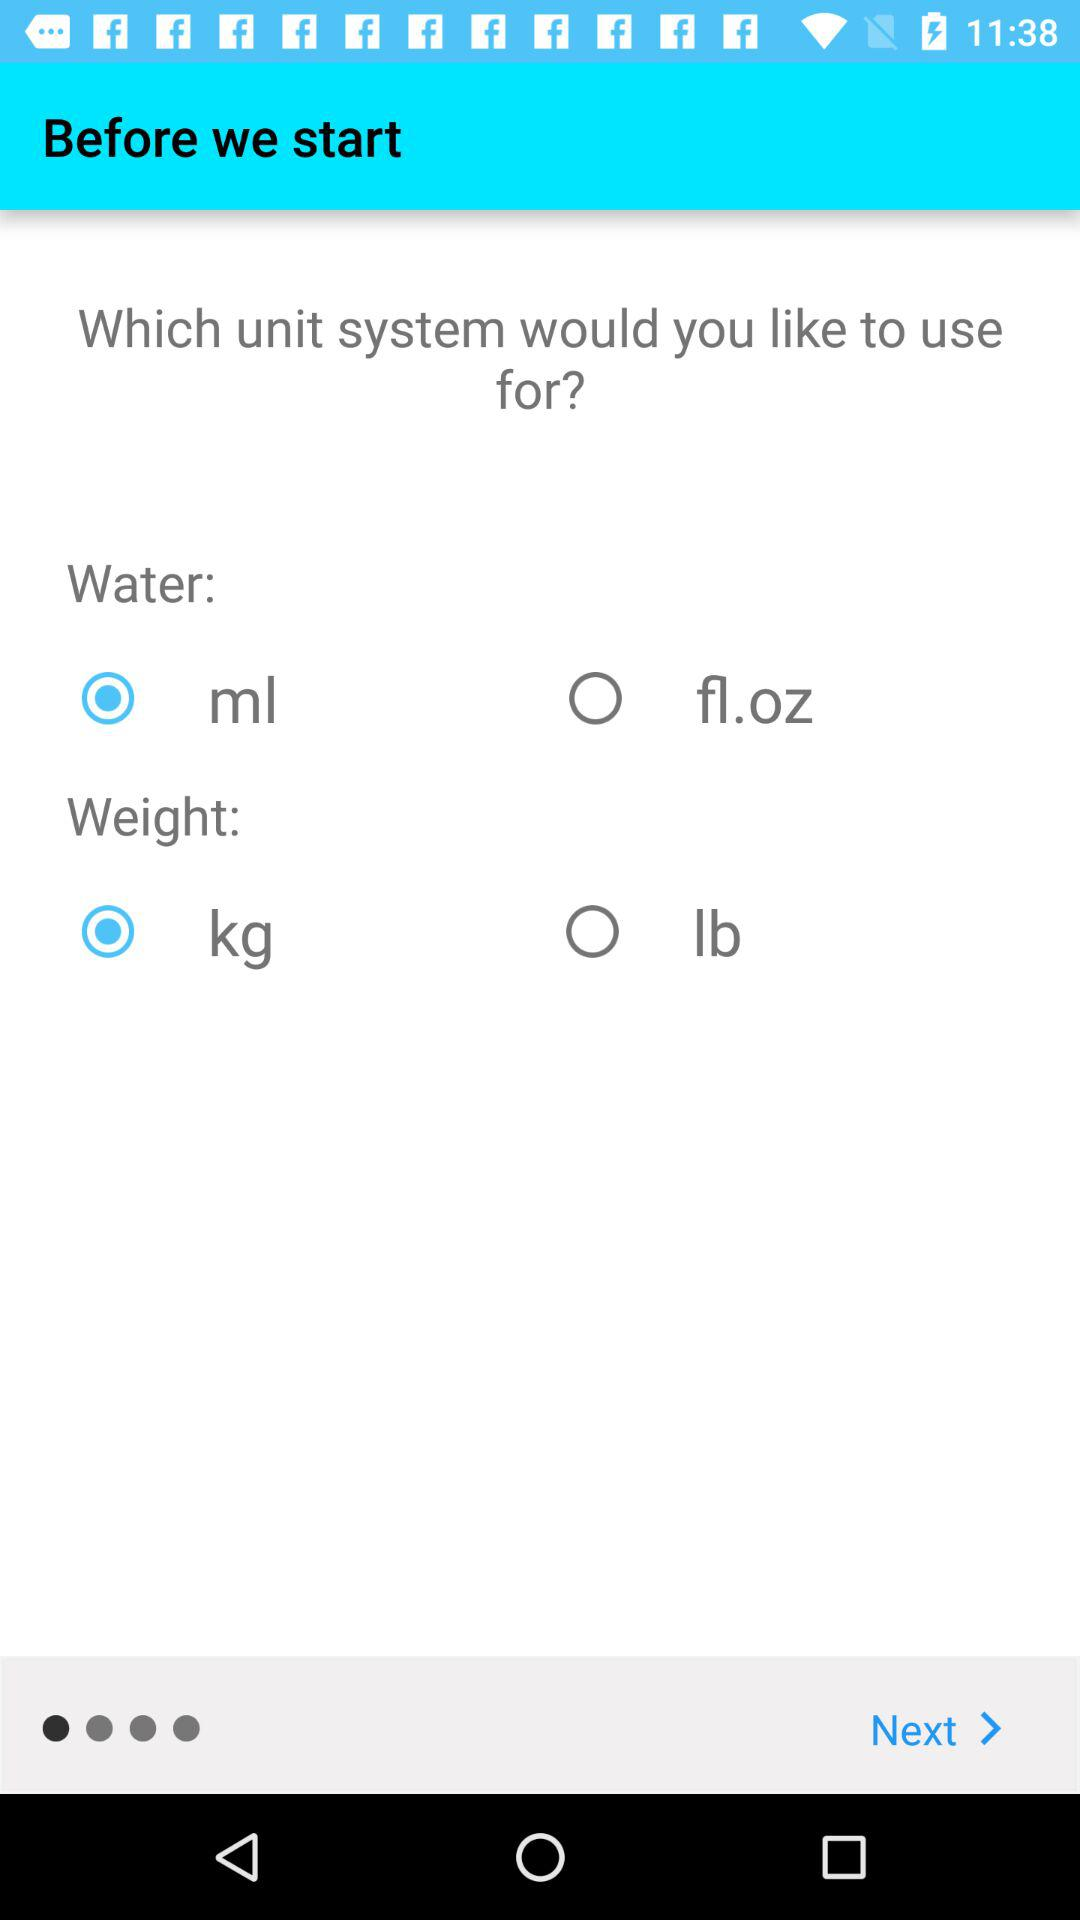How many unit systems are there?
Answer the question using a single word or phrase. 2 